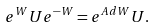Convert formula to latex. <formula><loc_0><loc_0><loc_500><loc_500>e ^ { W } U e ^ { - W } = e ^ { A d W } U .</formula> 